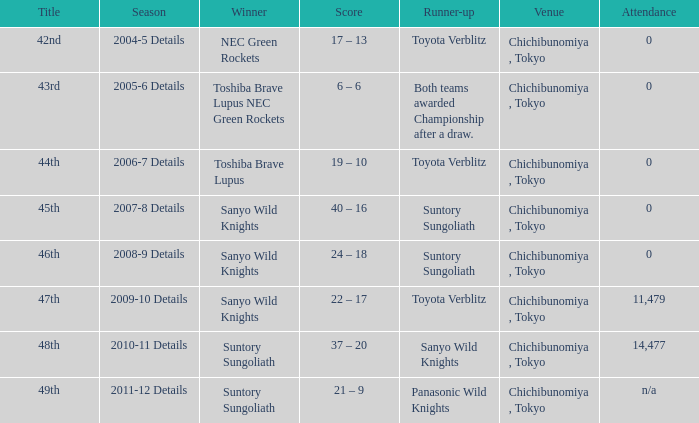What is the number of attendees for the rank of 44th? 0.0. 